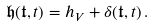Convert formula to latex. <formula><loc_0><loc_0><loc_500><loc_500>\mathfrak { h } ( \mathfrak { t } , t ) = h _ { V } + \delta ( \mathfrak { t } , t ) \, .</formula> 